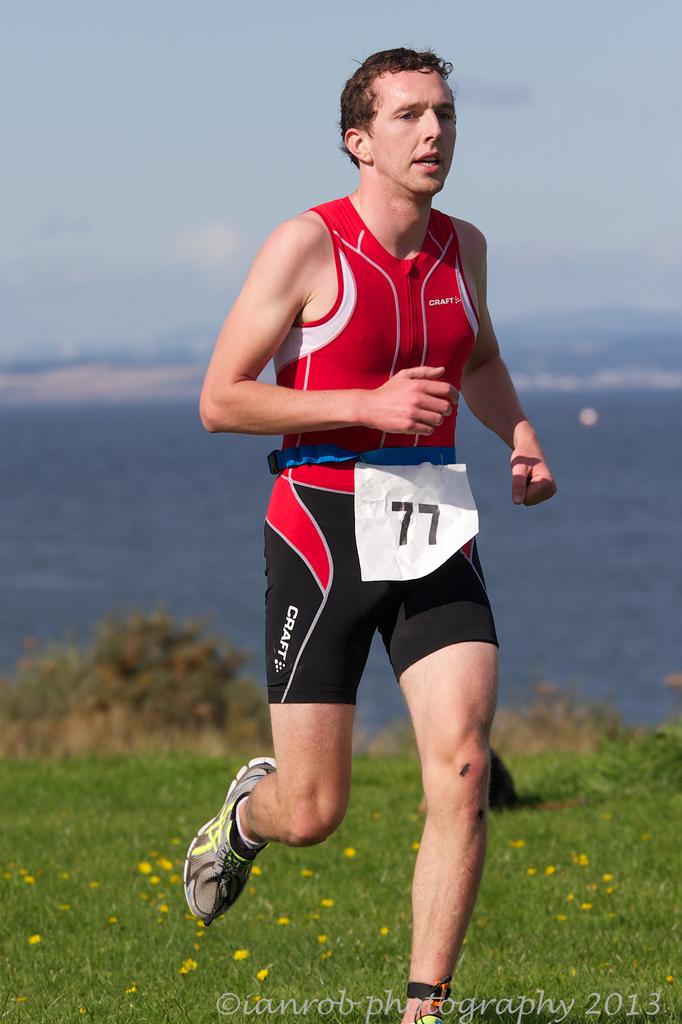What color is the number on this person?
Your answer should be compact. Answering does not require reading text in the image. 